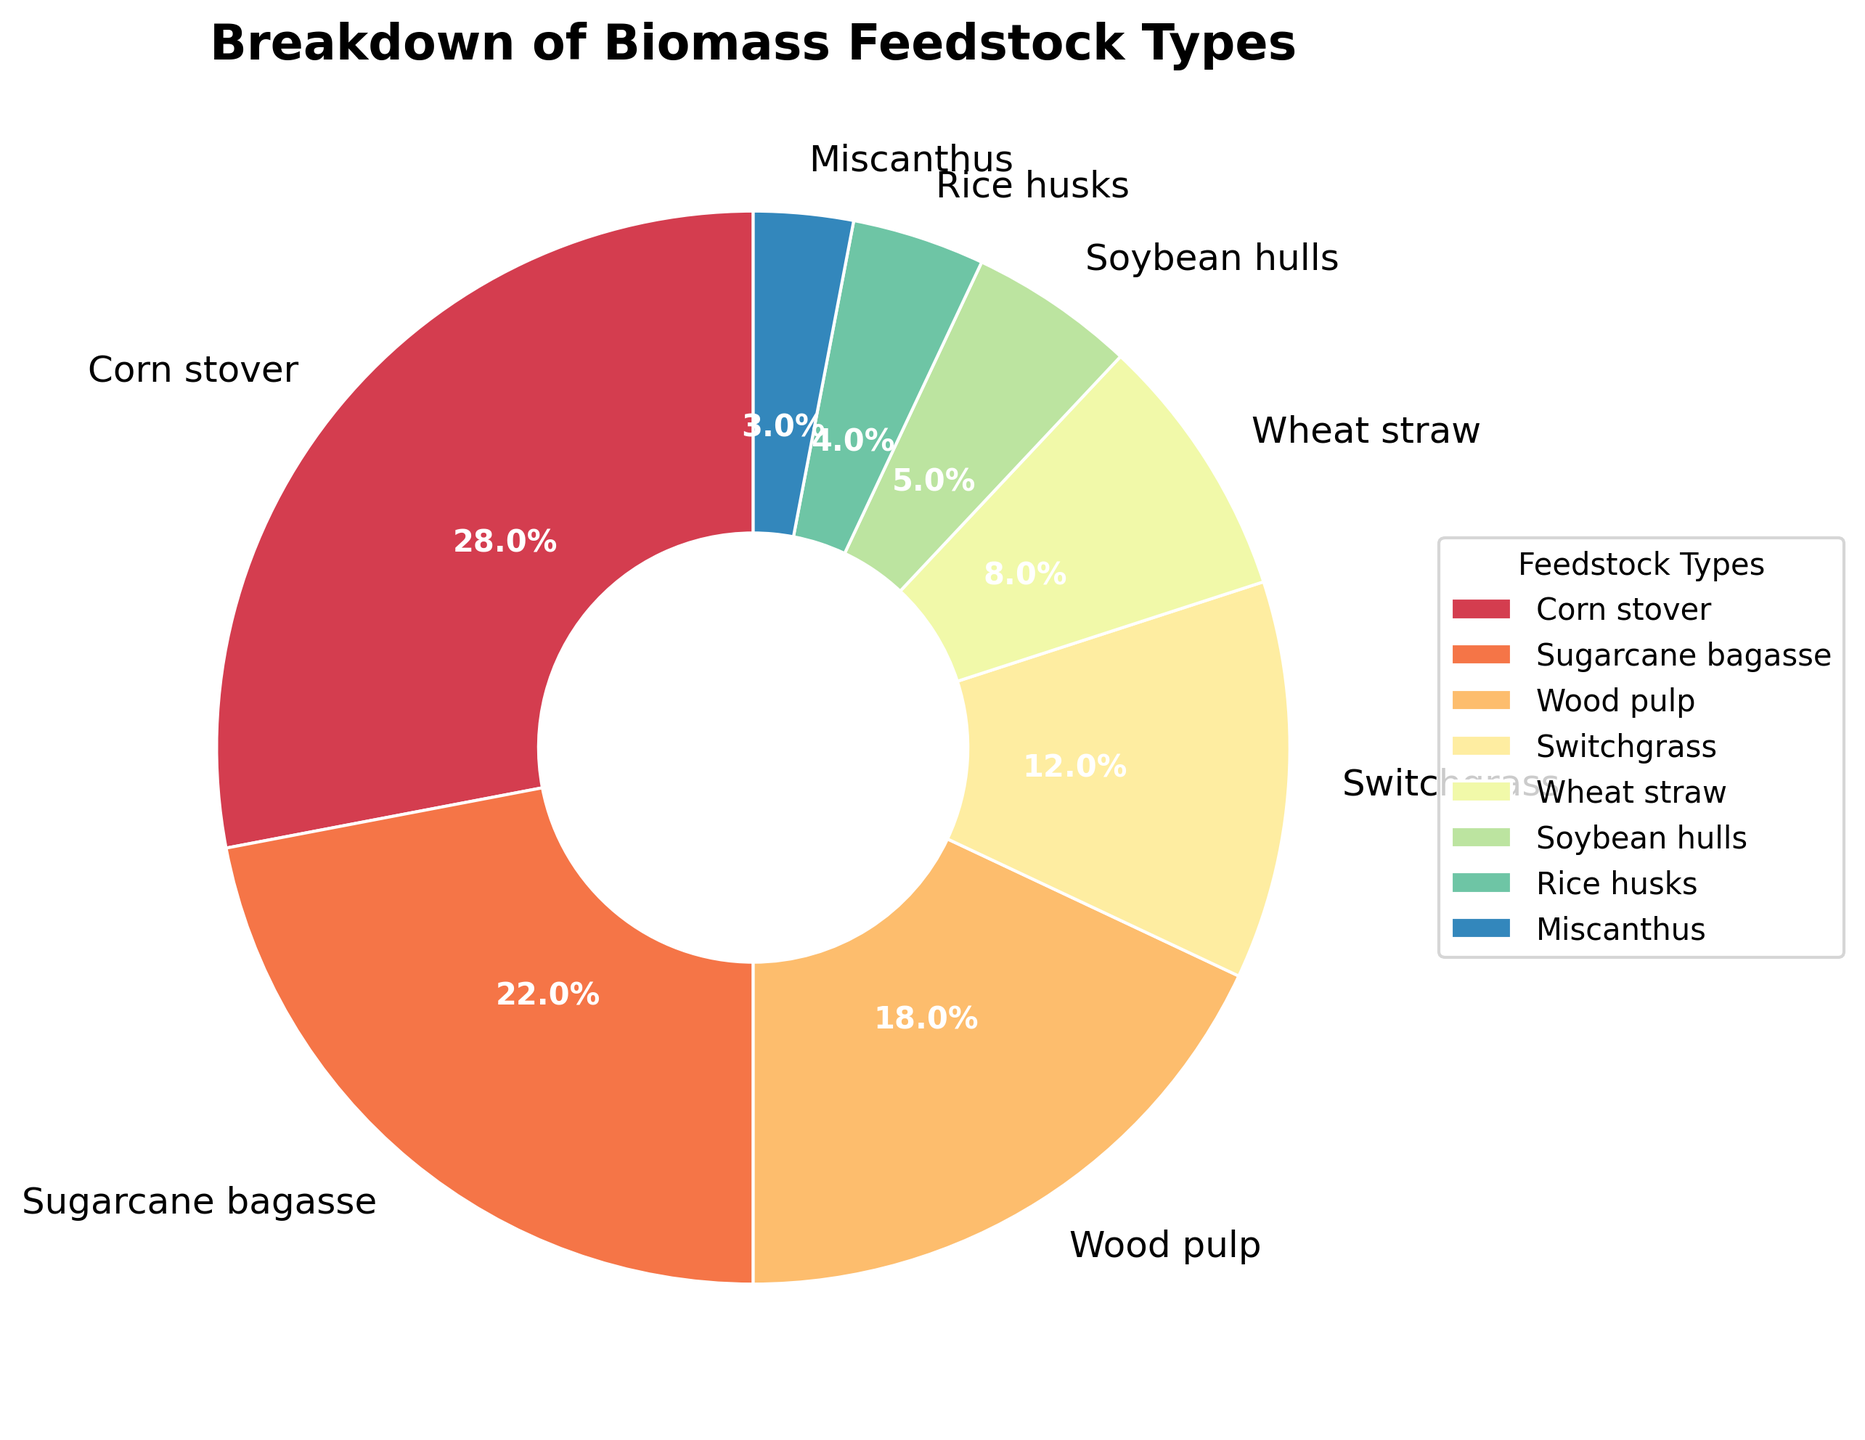Which biomass feedstock type has the highest percentage? The pie chart shows the percentages of different biomass feedstock types, and the highest percentage can be identified as the largest wedge in the chart. In this case, Corn stover has the highest percentage.
Answer: Corn stover What is the combined percentage of Sugarcane bagasse and Wood pulp? To find the combined percentage of Sugarcane bagasse and Wood pulp, sum their individual percentages: 22% (Sugarcane bagasse) + 18% (Wood pulp) = 40%.
Answer: 40% Is the percentage of Switchgrass more than that of Wheat straw and Miscanthus combined? Compare the percentage of Switchgrass with the combined percentage of Wheat straw and Miscanthus: 12% (Switchgrass) vs. 8% (Wheat straw) + 3% (Miscanthus) = 11%. Since 12% is greater than 11%, the answer is yes.
Answer: Yes Which biomass feedstock is represented by the second smallest wedge, and what is its percentage? The second smallest wedge in the pie chart will be just slightly larger than the smallest one. The smallest wedge represents Miscanthus (3%), so the next smallest is Rice husks at 4%.
Answer: Rice husks, 4% What is the difference between the percentages of Corn stover and Soybean hulls? Subtract the percentage of Soybean hulls from the percentage of Corn stover: 28% (Corn stover) - 5% (Soybean hulls) = 23%.
Answer: 23% Compare the sum of the percentages of the three largest feedstock types to the sum of the percentages of the three smallest feedstock types. Which is greater? First, identify the three largest percentages (Corn stover: 28%, Sugarcane bagasse: 22%, Wood pulp: 18%) and sum them: 28% + 22% + 18% = 68%. Then, identify the three smallest percentages (Miscanthus: 3%, Rice husks: 4%, Soybean hulls: 5%) and sum them: 3% + 4% + 5% = 12%. 68% is greater than 12%.
Answer: The sum of the three largest feedstock types is greater What is the percentage representation difference between the largest and smallest segments of the pie chart? Subtract the smallest segment percentage (Miscanthus: 3%) from the largest segment percentage (Corn stover: 28%): 28% - 3% = 25%.
Answer: 25% Which feedstock types have a combined percentage closest to 50%? First, identify combinations of feedstock types that add up to close to 50%. For example, Corn stover (28%) + Sugarcane bagasse (22%) = 50%. This combination is exactly 50%.
Answer: Corn stover and Sugarcane bagasse How does the percentage of Wood pulp compare to that of Rice husks and Wheat straw combined? Compare the percentage of Wood pulp (18%) with the combined percentage of Rice husks (4%) and Wheat straw (8%): 4% + 8% = 12%. Since 18% is greater than 12%, the answer is that Wood pulp's percentage is greater.
Answer: Wood pulp's percentage is greater 